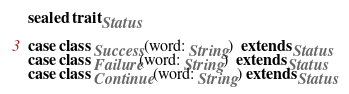<code> <loc_0><loc_0><loc_500><loc_500><_Scala_>sealed trait Status

case class Success(word: String)  extends Status
case class Failure(word: String)  extends Status
case class Continue(word: String) extends Status
</code> 